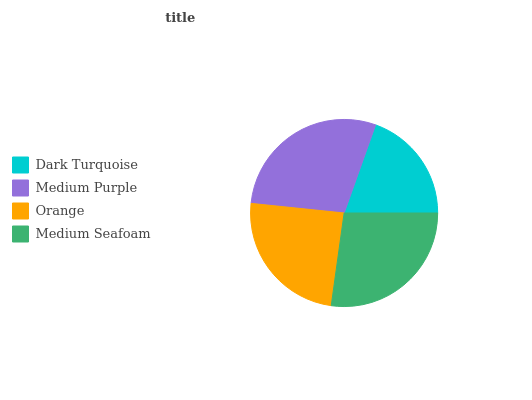Is Dark Turquoise the minimum?
Answer yes or no. Yes. Is Medium Purple the maximum?
Answer yes or no. Yes. Is Orange the minimum?
Answer yes or no. No. Is Orange the maximum?
Answer yes or no. No. Is Medium Purple greater than Orange?
Answer yes or no. Yes. Is Orange less than Medium Purple?
Answer yes or no. Yes. Is Orange greater than Medium Purple?
Answer yes or no. No. Is Medium Purple less than Orange?
Answer yes or no. No. Is Medium Seafoam the high median?
Answer yes or no. Yes. Is Orange the low median?
Answer yes or no. Yes. Is Orange the high median?
Answer yes or no. No. Is Medium Seafoam the low median?
Answer yes or no. No. 